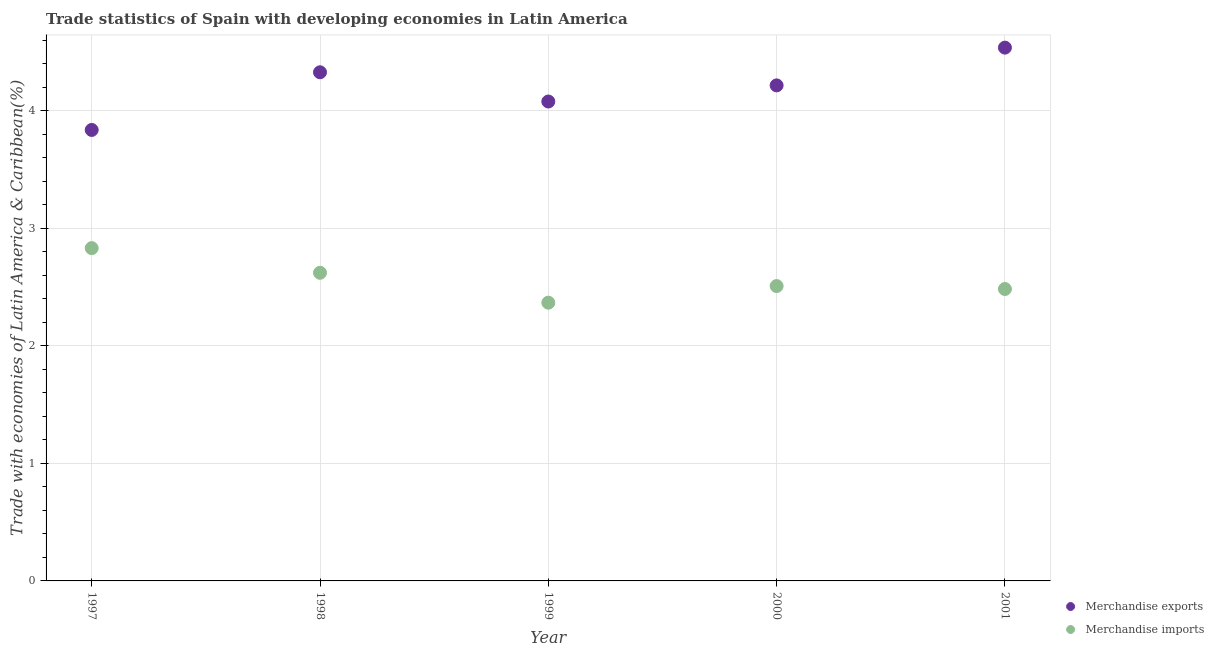What is the merchandise imports in 1999?
Make the answer very short. 2.37. Across all years, what is the maximum merchandise imports?
Provide a short and direct response. 2.83. Across all years, what is the minimum merchandise exports?
Provide a succinct answer. 3.84. In which year was the merchandise exports maximum?
Your response must be concise. 2001. In which year was the merchandise exports minimum?
Your answer should be very brief. 1997. What is the total merchandise exports in the graph?
Provide a succinct answer. 21. What is the difference between the merchandise imports in 1997 and that in 2000?
Provide a succinct answer. 0.32. What is the difference between the merchandise imports in 1999 and the merchandise exports in 1998?
Your response must be concise. -1.96. What is the average merchandise imports per year?
Your answer should be compact. 2.56. In the year 2001, what is the difference between the merchandise exports and merchandise imports?
Ensure brevity in your answer.  2.05. What is the ratio of the merchandise imports in 1998 to that in 1999?
Your answer should be compact. 1.11. Is the merchandise exports in 2000 less than that in 2001?
Offer a very short reply. Yes. What is the difference between the highest and the second highest merchandise exports?
Your response must be concise. 0.21. What is the difference between the highest and the lowest merchandise imports?
Offer a very short reply. 0.46. In how many years, is the merchandise exports greater than the average merchandise exports taken over all years?
Your answer should be very brief. 3. Is the merchandise imports strictly less than the merchandise exports over the years?
Offer a terse response. Yes. How many dotlines are there?
Make the answer very short. 2. How many years are there in the graph?
Keep it short and to the point. 5. Are the values on the major ticks of Y-axis written in scientific E-notation?
Offer a terse response. No. How many legend labels are there?
Give a very brief answer. 2. How are the legend labels stacked?
Offer a very short reply. Vertical. What is the title of the graph?
Keep it short and to the point. Trade statistics of Spain with developing economies in Latin America. What is the label or title of the Y-axis?
Offer a very short reply. Trade with economies of Latin America & Caribbean(%). What is the Trade with economies of Latin America & Caribbean(%) in Merchandise exports in 1997?
Your answer should be compact. 3.84. What is the Trade with economies of Latin America & Caribbean(%) in Merchandise imports in 1997?
Your answer should be very brief. 2.83. What is the Trade with economies of Latin America & Caribbean(%) in Merchandise exports in 1998?
Make the answer very short. 4.33. What is the Trade with economies of Latin America & Caribbean(%) of Merchandise imports in 1998?
Offer a terse response. 2.62. What is the Trade with economies of Latin America & Caribbean(%) of Merchandise exports in 1999?
Provide a short and direct response. 4.08. What is the Trade with economies of Latin America & Caribbean(%) in Merchandise imports in 1999?
Offer a very short reply. 2.37. What is the Trade with economies of Latin America & Caribbean(%) of Merchandise exports in 2000?
Ensure brevity in your answer.  4.22. What is the Trade with economies of Latin America & Caribbean(%) of Merchandise imports in 2000?
Ensure brevity in your answer.  2.51. What is the Trade with economies of Latin America & Caribbean(%) in Merchandise exports in 2001?
Provide a succinct answer. 4.54. What is the Trade with economies of Latin America & Caribbean(%) of Merchandise imports in 2001?
Keep it short and to the point. 2.48. Across all years, what is the maximum Trade with economies of Latin America & Caribbean(%) in Merchandise exports?
Ensure brevity in your answer.  4.54. Across all years, what is the maximum Trade with economies of Latin America & Caribbean(%) in Merchandise imports?
Ensure brevity in your answer.  2.83. Across all years, what is the minimum Trade with economies of Latin America & Caribbean(%) in Merchandise exports?
Offer a very short reply. 3.84. Across all years, what is the minimum Trade with economies of Latin America & Caribbean(%) in Merchandise imports?
Ensure brevity in your answer.  2.37. What is the total Trade with economies of Latin America & Caribbean(%) of Merchandise exports in the graph?
Ensure brevity in your answer.  21. What is the total Trade with economies of Latin America & Caribbean(%) in Merchandise imports in the graph?
Provide a short and direct response. 12.81. What is the difference between the Trade with economies of Latin America & Caribbean(%) in Merchandise exports in 1997 and that in 1998?
Provide a short and direct response. -0.49. What is the difference between the Trade with economies of Latin America & Caribbean(%) of Merchandise imports in 1997 and that in 1998?
Offer a terse response. 0.21. What is the difference between the Trade with economies of Latin America & Caribbean(%) of Merchandise exports in 1997 and that in 1999?
Your answer should be compact. -0.24. What is the difference between the Trade with economies of Latin America & Caribbean(%) of Merchandise imports in 1997 and that in 1999?
Your response must be concise. 0.46. What is the difference between the Trade with economies of Latin America & Caribbean(%) of Merchandise exports in 1997 and that in 2000?
Offer a very short reply. -0.38. What is the difference between the Trade with economies of Latin America & Caribbean(%) in Merchandise imports in 1997 and that in 2000?
Offer a very short reply. 0.32. What is the difference between the Trade with economies of Latin America & Caribbean(%) in Merchandise exports in 1997 and that in 2001?
Provide a short and direct response. -0.7. What is the difference between the Trade with economies of Latin America & Caribbean(%) of Merchandise imports in 1997 and that in 2001?
Ensure brevity in your answer.  0.35. What is the difference between the Trade with economies of Latin America & Caribbean(%) of Merchandise exports in 1998 and that in 1999?
Make the answer very short. 0.25. What is the difference between the Trade with economies of Latin America & Caribbean(%) of Merchandise imports in 1998 and that in 1999?
Offer a terse response. 0.25. What is the difference between the Trade with economies of Latin America & Caribbean(%) in Merchandise exports in 1998 and that in 2000?
Keep it short and to the point. 0.11. What is the difference between the Trade with economies of Latin America & Caribbean(%) in Merchandise imports in 1998 and that in 2000?
Provide a short and direct response. 0.11. What is the difference between the Trade with economies of Latin America & Caribbean(%) in Merchandise exports in 1998 and that in 2001?
Your response must be concise. -0.21. What is the difference between the Trade with economies of Latin America & Caribbean(%) in Merchandise imports in 1998 and that in 2001?
Your response must be concise. 0.14. What is the difference between the Trade with economies of Latin America & Caribbean(%) of Merchandise exports in 1999 and that in 2000?
Provide a short and direct response. -0.14. What is the difference between the Trade with economies of Latin America & Caribbean(%) of Merchandise imports in 1999 and that in 2000?
Ensure brevity in your answer.  -0.14. What is the difference between the Trade with economies of Latin America & Caribbean(%) of Merchandise exports in 1999 and that in 2001?
Keep it short and to the point. -0.46. What is the difference between the Trade with economies of Latin America & Caribbean(%) of Merchandise imports in 1999 and that in 2001?
Keep it short and to the point. -0.12. What is the difference between the Trade with economies of Latin America & Caribbean(%) of Merchandise exports in 2000 and that in 2001?
Provide a succinct answer. -0.32. What is the difference between the Trade with economies of Latin America & Caribbean(%) of Merchandise imports in 2000 and that in 2001?
Your answer should be compact. 0.03. What is the difference between the Trade with economies of Latin America & Caribbean(%) in Merchandise exports in 1997 and the Trade with economies of Latin America & Caribbean(%) in Merchandise imports in 1998?
Provide a short and direct response. 1.22. What is the difference between the Trade with economies of Latin America & Caribbean(%) of Merchandise exports in 1997 and the Trade with economies of Latin America & Caribbean(%) of Merchandise imports in 1999?
Ensure brevity in your answer.  1.47. What is the difference between the Trade with economies of Latin America & Caribbean(%) in Merchandise exports in 1997 and the Trade with economies of Latin America & Caribbean(%) in Merchandise imports in 2000?
Offer a terse response. 1.33. What is the difference between the Trade with economies of Latin America & Caribbean(%) in Merchandise exports in 1997 and the Trade with economies of Latin America & Caribbean(%) in Merchandise imports in 2001?
Offer a very short reply. 1.35. What is the difference between the Trade with economies of Latin America & Caribbean(%) of Merchandise exports in 1998 and the Trade with economies of Latin America & Caribbean(%) of Merchandise imports in 1999?
Offer a terse response. 1.96. What is the difference between the Trade with economies of Latin America & Caribbean(%) in Merchandise exports in 1998 and the Trade with economies of Latin America & Caribbean(%) in Merchandise imports in 2000?
Your answer should be very brief. 1.82. What is the difference between the Trade with economies of Latin America & Caribbean(%) in Merchandise exports in 1998 and the Trade with economies of Latin America & Caribbean(%) in Merchandise imports in 2001?
Keep it short and to the point. 1.84. What is the difference between the Trade with economies of Latin America & Caribbean(%) in Merchandise exports in 1999 and the Trade with economies of Latin America & Caribbean(%) in Merchandise imports in 2000?
Provide a succinct answer. 1.57. What is the difference between the Trade with economies of Latin America & Caribbean(%) of Merchandise exports in 1999 and the Trade with economies of Latin America & Caribbean(%) of Merchandise imports in 2001?
Make the answer very short. 1.6. What is the difference between the Trade with economies of Latin America & Caribbean(%) in Merchandise exports in 2000 and the Trade with economies of Latin America & Caribbean(%) in Merchandise imports in 2001?
Provide a short and direct response. 1.73. What is the average Trade with economies of Latin America & Caribbean(%) of Merchandise exports per year?
Your response must be concise. 4.2. What is the average Trade with economies of Latin America & Caribbean(%) in Merchandise imports per year?
Ensure brevity in your answer.  2.56. In the year 1997, what is the difference between the Trade with economies of Latin America & Caribbean(%) in Merchandise exports and Trade with economies of Latin America & Caribbean(%) in Merchandise imports?
Make the answer very short. 1.01. In the year 1998, what is the difference between the Trade with economies of Latin America & Caribbean(%) of Merchandise exports and Trade with economies of Latin America & Caribbean(%) of Merchandise imports?
Offer a very short reply. 1.71. In the year 1999, what is the difference between the Trade with economies of Latin America & Caribbean(%) of Merchandise exports and Trade with economies of Latin America & Caribbean(%) of Merchandise imports?
Your response must be concise. 1.71. In the year 2000, what is the difference between the Trade with economies of Latin America & Caribbean(%) of Merchandise exports and Trade with economies of Latin America & Caribbean(%) of Merchandise imports?
Ensure brevity in your answer.  1.71. In the year 2001, what is the difference between the Trade with economies of Latin America & Caribbean(%) in Merchandise exports and Trade with economies of Latin America & Caribbean(%) in Merchandise imports?
Offer a terse response. 2.05. What is the ratio of the Trade with economies of Latin America & Caribbean(%) in Merchandise exports in 1997 to that in 1998?
Give a very brief answer. 0.89. What is the ratio of the Trade with economies of Latin America & Caribbean(%) in Merchandise exports in 1997 to that in 1999?
Give a very brief answer. 0.94. What is the ratio of the Trade with economies of Latin America & Caribbean(%) of Merchandise imports in 1997 to that in 1999?
Your answer should be compact. 1.2. What is the ratio of the Trade with economies of Latin America & Caribbean(%) of Merchandise exports in 1997 to that in 2000?
Provide a succinct answer. 0.91. What is the ratio of the Trade with economies of Latin America & Caribbean(%) in Merchandise imports in 1997 to that in 2000?
Provide a succinct answer. 1.13. What is the ratio of the Trade with economies of Latin America & Caribbean(%) of Merchandise exports in 1997 to that in 2001?
Offer a very short reply. 0.85. What is the ratio of the Trade with economies of Latin America & Caribbean(%) in Merchandise imports in 1997 to that in 2001?
Provide a succinct answer. 1.14. What is the ratio of the Trade with economies of Latin America & Caribbean(%) of Merchandise exports in 1998 to that in 1999?
Provide a short and direct response. 1.06. What is the ratio of the Trade with economies of Latin America & Caribbean(%) in Merchandise imports in 1998 to that in 1999?
Make the answer very short. 1.11. What is the ratio of the Trade with economies of Latin America & Caribbean(%) of Merchandise exports in 1998 to that in 2000?
Your answer should be very brief. 1.03. What is the ratio of the Trade with economies of Latin America & Caribbean(%) in Merchandise imports in 1998 to that in 2000?
Give a very brief answer. 1.05. What is the ratio of the Trade with economies of Latin America & Caribbean(%) of Merchandise exports in 1998 to that in 2001?
Your answer should be compact. 0.95. What is the ratio of the Trade with economies of Latin America & Caribbean(%) of Merchandise imports in 1998 to that in 2001?
Offer a terse response. 1.06. What is the ratio of the Trade with economies of Latin America & Caribbean(%) in Merchandise exports in 1999 to that in 2000?
Keep it short and to the point. 0.97. What is the ratio of the Trade with economies of Latin America & Caribbean(%) in Merchandise imports in 1999 to that in 2000?
Your answer should be very brief. 0.94. What is the ratio of the Trade with economies of Latin America & Caribbean(%) in Merchandise exports in 1999 to that in 2001?
Provide a short and direct response. 0.9. What is the ratio of the Trade with economies of Latin America & Caribbean(%) in Merchandise imports in 1999 to that in 2001?
Your answer should be very brief. 0.95. What is the ratio of the Trade with economies of Latin America & Caribbean(%) in Merchandise exports in 2000 to that in 2001?
Your answer should be compact. 0.93. What is the difference between the highest and the second highest Trade with economies of Latin America & Caribbean(%) of Merchandise exports?
Keep it short and to the point. 0.21. What is the difference between the highest and the second highest Trade with economies of Latin America & Caribbean(%) in Merchandise imports?
Make the answer very short. 0.21. What is the difference between the highest and the lowest Trade with economies of Latin America & Caribbean(%) of Merchandise exports?
Your answer should be very brief. 0.7. What is the difference between the highest and the lowest Trade with economies of Latin America & Caribbean(%) in Merchandise imports?
Your response must be concise. 0.46. 